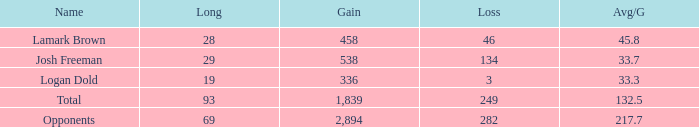How much Gain has a Long of 29, and an Avg/G smaller than 33.7? 0.0. 